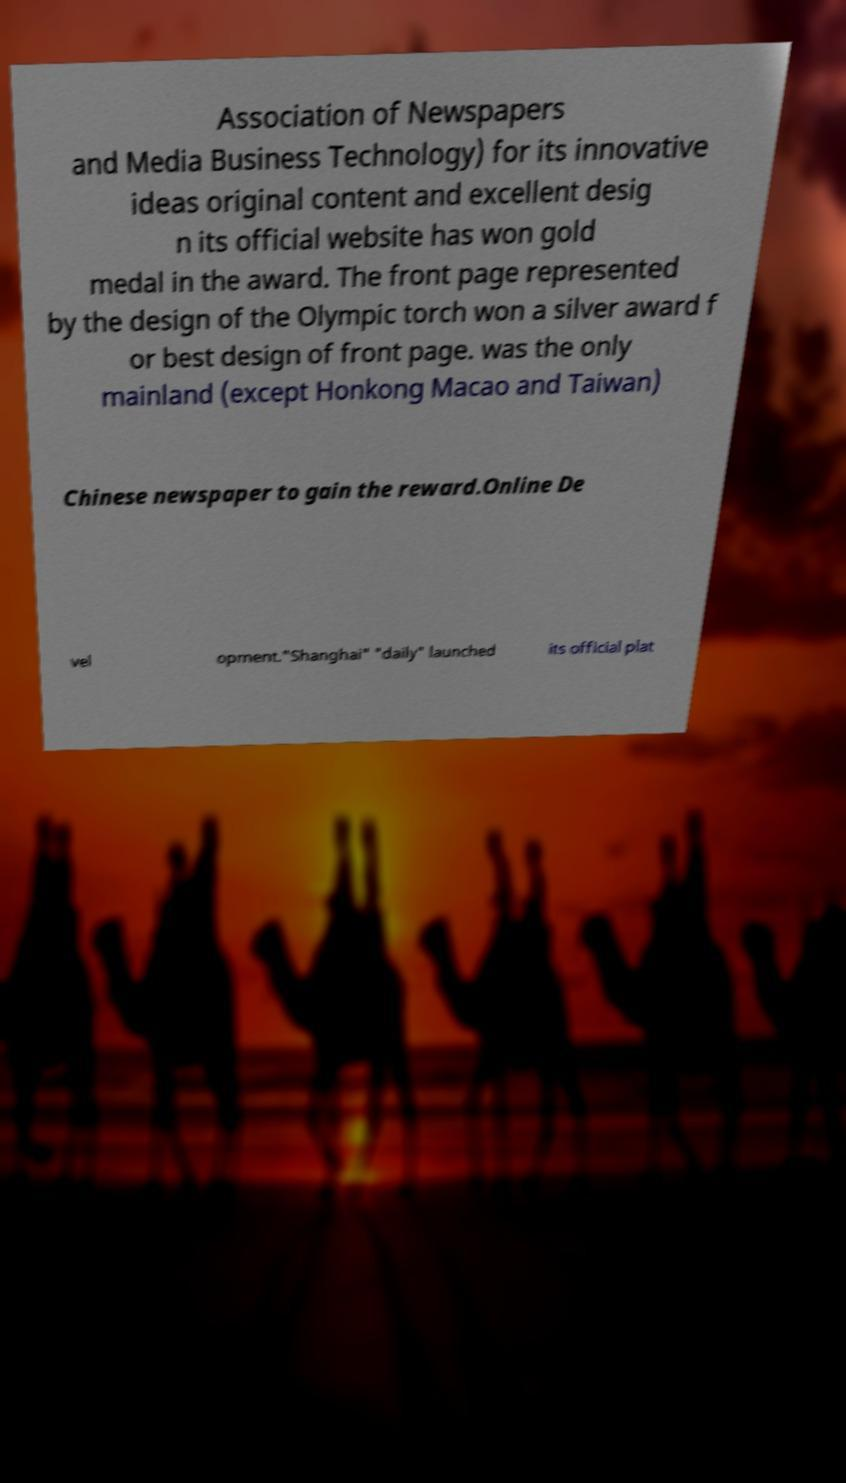I need the written content from this picture converted into text. Can you do that? Association of Newspapers and Media Business Technology) for its innovative ideas original content and excellent desig n its official website has won gold medal in the award. The front page represented by the design of the Olympic torch won a silver award f or best design of front page. was the only mainland (except Honkong Macao and Taiwan) Chinese newspaper to gain the reward.Online De vel opment."Shanghai" "daily" launched its official plat 